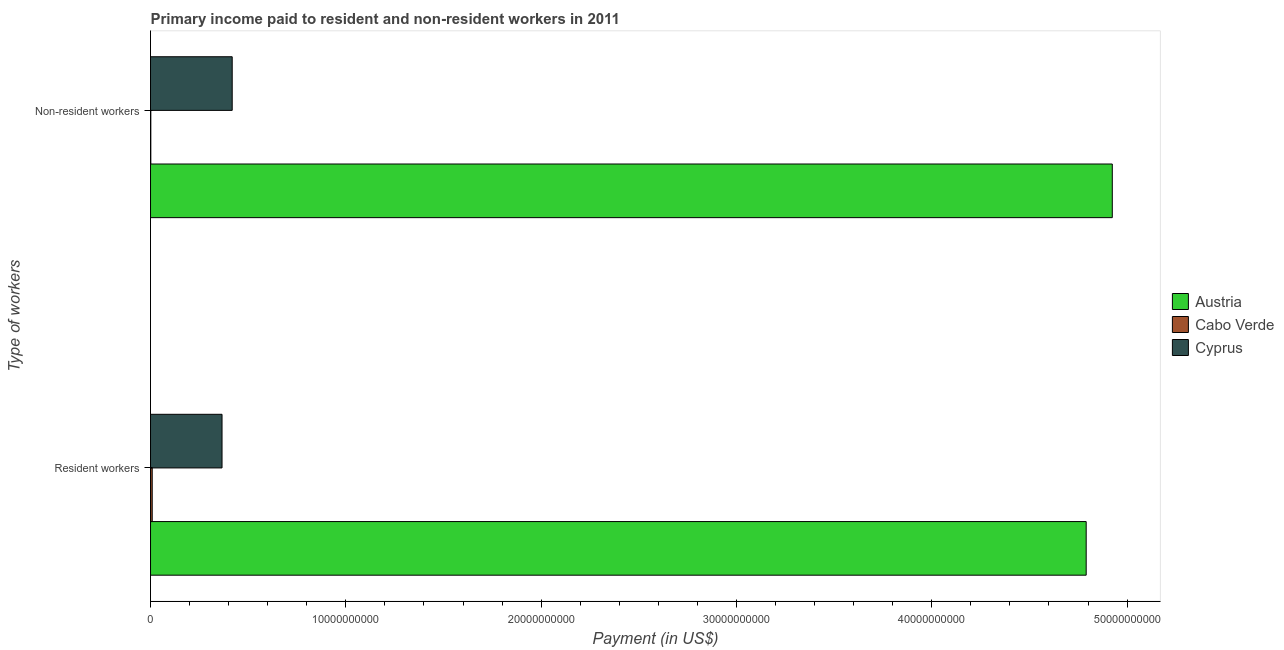How many groups of bars are there?
Provide a succinct answer. 2. Are the number of bars per tick equal to the number of legend labels?
Offer a very short reply. Yes. Are the number of bars on each tick of the Y-axis equal?
Give a very brief answer. Yes. How many bars are there on the 2nd tick from the top?
Ensure brevity in your answer.  3. How many bars are there on the 2nd tick from the bottom?
Offer a very short reply. 3. What is the label of the 1st group of bars from the top?
Ensure brevity in your answer.  Non-resident workers. What is the payment made to resident workers in Austria?
Give a very brief answer. 4.79e+1. Across all countries, what is the maximum payment made to resident workers?
Ensure brevity in your answer.  4.79e+1. Across all countries, what is the minimum payment made to resident workers?
Give a very brief answer. 8.60e+07. In which country was the payment made to resident workers minimum?
Offer a terse response. Cabo Verde. What is the total payment made to non-resident workers in the graph?
Provide a short and direct response. 5.34e+1. What is the difference between the payment made to resident workers in Cyprus and that in Cabo Verde?
Provide a succinct answer. 3.57e+09. What is the difference between the payment made to resident workers in Austria and the payment made to non-resident workers in Cyprus?
Your answer should be compact. 4.37e+1. What is the average payment made to resident workers per country?
Offer a very short reply. 1.72e+1. What is the difference between the payment made to non-resident workers and payment made to resident workers in Austria?
Your answer should be compact. 1.34e+09. In how many countries, is the payment made to resident workers greater than 30000000000 US$?
Make the answer very short. 1. What is the ratio of the payment made to non-resident workers in Cabo Verde to that in Cyprus?
Give a very brief answer. 0. In how many countries, is the payment made to non-resident workers greater than the average payment made to non-resident workers taken over all countries?
Provide a succinct answer. 1. What does the 2nd bar from the top in Non-resident workers represents?
Offer a very short reply. Cabo Verde. What does the 3rd bar from the bottom in Resident workers represents?
Provide a short and direct response. Cyprus. How many bars are there?
Ensure brevity in your answer.  6. What is the difference between two consecutive major ticks on the X-axis?
Your answer should be very brief. 1.00e+1. Does the graph contain grids?
Your response must be concise. No. Where does the legend appear in the graph?
Keep it short and to the point. Center right. How many legend labels are there?
Provide a short and direct response. 3. What is the title of the graph?
Your answer should be compact. Primary income paid to resident and non-resident workers in 2011. Does "Zambia" appear as one of the legend labels in the graph?
Your response must be concise. No. What is the label or title of the X-axis?
Make the answer very short. Payment (in US$). What is the label or title of the Y-axis?
Your answer should be very brief. Type of workers. What is the Payment (in US$) of Austria in Resident workers?
Your answer should be compact. 4.79e+1. What is the Payment (in US$) of Cabo Verde in Resident workers?
Offer a very short reply. 8.60e+07. What is the Payment (in US$) in Cyprus in Resident workers?
Ensure brevity in your answer.  3.66e+09. What is the Payment (in US$) of Austria in Non-resident workers?
Keep it short and to the point. 4.92e+1. What is the Payment (in US$) of Cabo Verde in Non-resident workers?
Keep it short and to the point. 1.43e+07. What is the Payment (in US$) in Cyprus in Non-resident workers?
Your answer should be very brief. 4.18e+09. Across all Type of workers, what is the maximum Payment (in US$) in Austria?
Your answer should be compact. 4.92e+1. Across all Type of workers, what is the maximum Payment (in US$) in Cabo Verde?
Your answer should be very brief. 8.60e+07. Across all Type of workers, what is the maximum Payment (in US$) of Cyprus?
Keep it short and to the point. 4.18e+09. Across all Type of workers, what is the minimum Payment (in US$) in Austria?
Give a very brief answer. 4.79e+1. Across all Type of workers, what is the minimum Payment (in US$) in Cabo Verde?
Ensure brevity in your answer.  1.43e+07. Across all Type of workers, what is the minimum Payment (in US$) of Cyprus?
Provide a short and direct response. 3.66e+09. What is the total Payment (in US$) of Austria in the graph?
Your answer should be very brief. 9.71e+1. What is the total Payment (in US$) in Cabo Verde in the graph?
Offer a terse response. 1.00e+08. What is the total Payment (in US$) of Cyprus in the graph?
Offer a terse response. 7.84e+09. What is the difference between the Payment (in US$) of Austria in Resident workers and that in Non-resident workers?
Provide a short and direct response. -1.34e+09. What is the difference between the Payment (in US$) in Cabo Verde in Resident workers and that in Non-resident workers?
Provide a succinct answer. 7.18e+07. What is the difference between the Payment (in US$) of Cyprus in Resident workers and that in Non-resident workers?
Your answer should be very brief. -5.21e+08. What is the difference between the Payment (in US$) of Austria in Resident workers and the Payment (in US$) of Cabo Verde in Non-resident workers?
Your answer should be compact. 4.79e+1. What is the difference between the Payment (in US$) of Austria in Resident workers and the Payment (in US$) of Cyprus in Non-resident workers?
Provide a succinct answer. 4.37e+1. What is the difference between the Payment (in US$) of Cabo Verde in Resident workers and the Payment (in US$) of Cyprus in Non-resident workers?
Offer a very short reply. -4.10e+09. What is the average Payment (in US$) of Austria per Type of workers?
Offer a terse response. 4.86e+1. What is the average Payment (in US$) in Cabo Verde per Type of workers?
Offer a very short reply. 5.02e+07. What is the average Payment (in US$) in Cyprus per Type of workers?
Your answer should be compact. 3.92e+09. What is the difference between the Payment (in US$) in Austria and Payment (in US$) in Cabo Verde in Resident workers?
Offer a very short reply. 4.78e+1. What is the difference between the Payment (in US$) in Austria and Payment (in US$) in Cyprus in Resident workers?
Provide a short and direct response. 4.42e+1. What is the difference between the Payment (in US$) in Cabo Verde and Payment (in US$) in Cyprus in Resident workers?
Your answer should be very brief. -3.57e+09. What is the difference between the Payment (in US$) in Austria and Payment (in US$) in Cabo Verde in Non-resident workers?
Give a very brief answer. 4.92e+1. What is the difference between the Payment (in US$) of Austria and Payment (in US$) of Cyprus in Non-resident workers?
Your answer should be very brief. 4.51e+1. What is the difference between the Payment (in US$) in Cabo Verde and Payment (in US$) in Cyprus in Non-resident workers?
Offer a terse response. -4.17e+09. What is the ratio of the Payment (in US$) of Austria in Resident workers to that in Non-resident workers?
Ensure brevity in your answer.  0.97. What is the ratio of the Payment (in US$) in Cabo Verde in Resident workers to that in Non-resident workers?
Your answer should be compact. 6.03. What is the ratio of the Payment (in US$) in Cyprus in Resident workers to that in Non-resident workers?
Your answer should be very brief. 0.88. What is the difference between the highest and the second highest Payment (in US$) in Austria?
Make the answer very short. 1.34e+09. What is the difference between the highest and the second highest Payment (in US$) of Cabo Verde?
Offer a terse response. 7.18e+07. What is the difference between the highest and the second highest Payment (in US$) of Cyprus?
Offer a terse response. 5.21e+08. What is the difference between the highest and the lowest Payment (in US$) in Austria?
Provide a short and direct response. 1.34e+09. What is the difference between the highest and the lowest Payment (in US$) of Cabo Verde?
Give a very brief answer. 7.18e+07. What is the difference between the highest and the lowest Payment (in US$) of Cyprus?
Keep it short and to the point. 5.21e+08. 